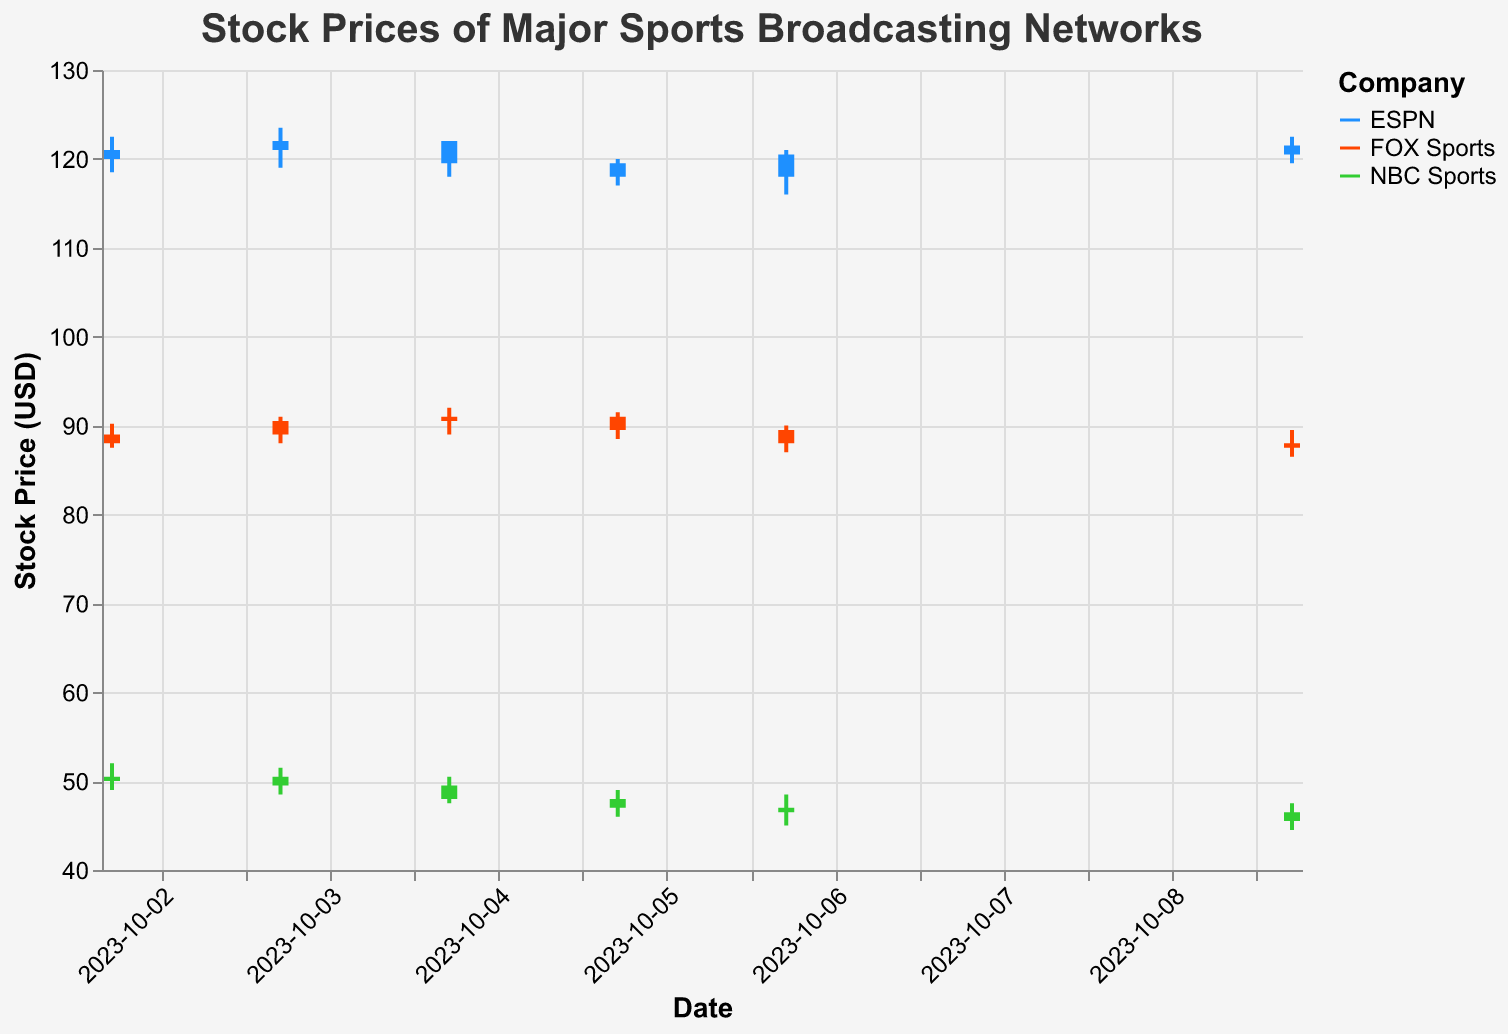What is the title of the figure? The title of the figure is the text displayed at the top center of the figure. It explains the content of the figure which in this case is about stock prices.
Answer: Stock Prices of Major Sports Broadcasting Networks On what date did ESPN have the highest closing stock price, and what was it? To find the highest closing stock price for ESPN, look at all the closing prices and find the maximum value, then check the corresponding date. The closest price for ESPN among the data is 122.00 on October 3rd.
Answer: October 3, 122.00 What is the average closing stock price of NBC Sports over the given dates? Add all the closing prices for NBC Sports and divide by the number of days listed (7 days). (50.50 + 49.50 + 48.00 + 47.00 + 46.50 + 45.50) / 7 = 43.61
Answer: 46.57 How does FOX Sports' closing price on October 9 compare to its opening price on the same date? Look at FOX Sports' opening price and closing price on October 9th. Compare the two values. Opening price: 88.00, Closing price: 87.50.
Answer: Closing price is lower by 0.50 Which company had the greatest range between high and low prices on October 6 and what was the value? Calculate the range (High - Low) for each company on October 6 and find the maximum range. ESPN: 121.00 - 116.00 = 5.00, FOX Sports: 90.00 - 87.00 = 3.00, NBC Sports: 48.50 - 45.00 = 3.50.
Answer: ESPN, 5.00 What was the closing stock price for ESPN on the last date in the data set? Look for the closing price of ESPN on the most recent date provided in the data set. The last date is October 9, and the closing price for ESPN on that date is 121.50.
Answer: 121.50 Across the given dates, which company saw a decrease in closing stock price most often? Count the number of times each company had a lower closing price compared to the previous day. ESPN: 3 (from 122.00 to 119.50 on Oct 4, from 119.50 to 118.00 on Oct 5, from 120.50 to 121.50 on Oct 9). FOX Sports: 3 (from 90.50 to 89.50 on Oct 5, from 89.50 to 88.00 on Oct 6, from 88.00 to 87.50 on Oct 9). NBC Sports: 4 (from 49.50 to 48.50 on Oct 4, from 48.00 to 47.00 on Oct 5, from 47.00 to 46.50 on Oct 6, from 46.50 to 45.50 on Oct 9). NBC Sports had the most decreases.
Answer: NBC Sports 